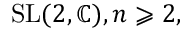<formula> <loc_0><loc_0><loc_500><loc_500>{ S L } ( 2 , \mathbb { C } ) , n \geqslant 2 ,</formula> 